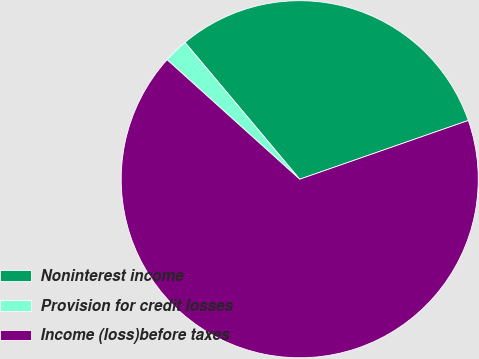Convert chart. <chart><loc_0><loc_0><loc_500><loc_500><pie_chart><fcel>Noninterest income<fcel>Provision for credit losses<fcel>Income (loss)before taxes<nl><fcel>30.77%<fcel>2.22%<fcel>67.01%<nl></chart> 